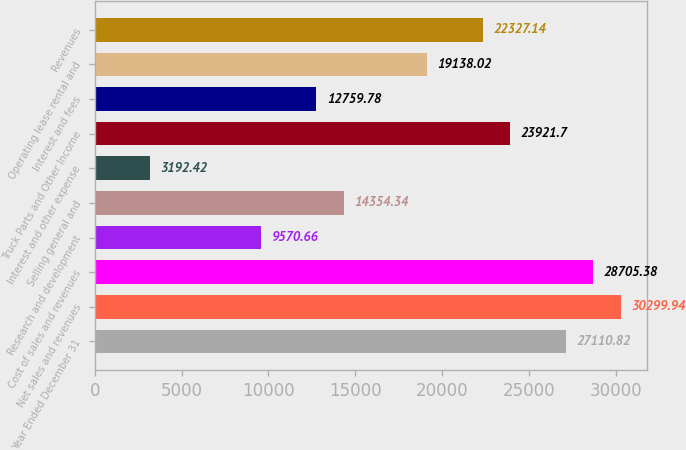Convert chart. <chart><loc_0><loc_0><loc_500><loc_500><bar_chart><fcel>Year Ended December 31<fcel>Net sales and revenues<fcel>Cost of sales and revenues<fcel>Research and development<fcel>Selling general and<fcel>Interest and other expense<fcel>Truck Parts and Other Income<fcel>Interest and fees<fcel>Operating lease rental and<fcel>Revenues<nl><fcel>27110.8<fcel>30299.9<fcel>28705.4<fcel>9570.66<fcel>14354.3<fcel>3192.42<fcel>23921.7<fcel>12759.8<fcel>19138<fcel>22327.1<nl></chart> 